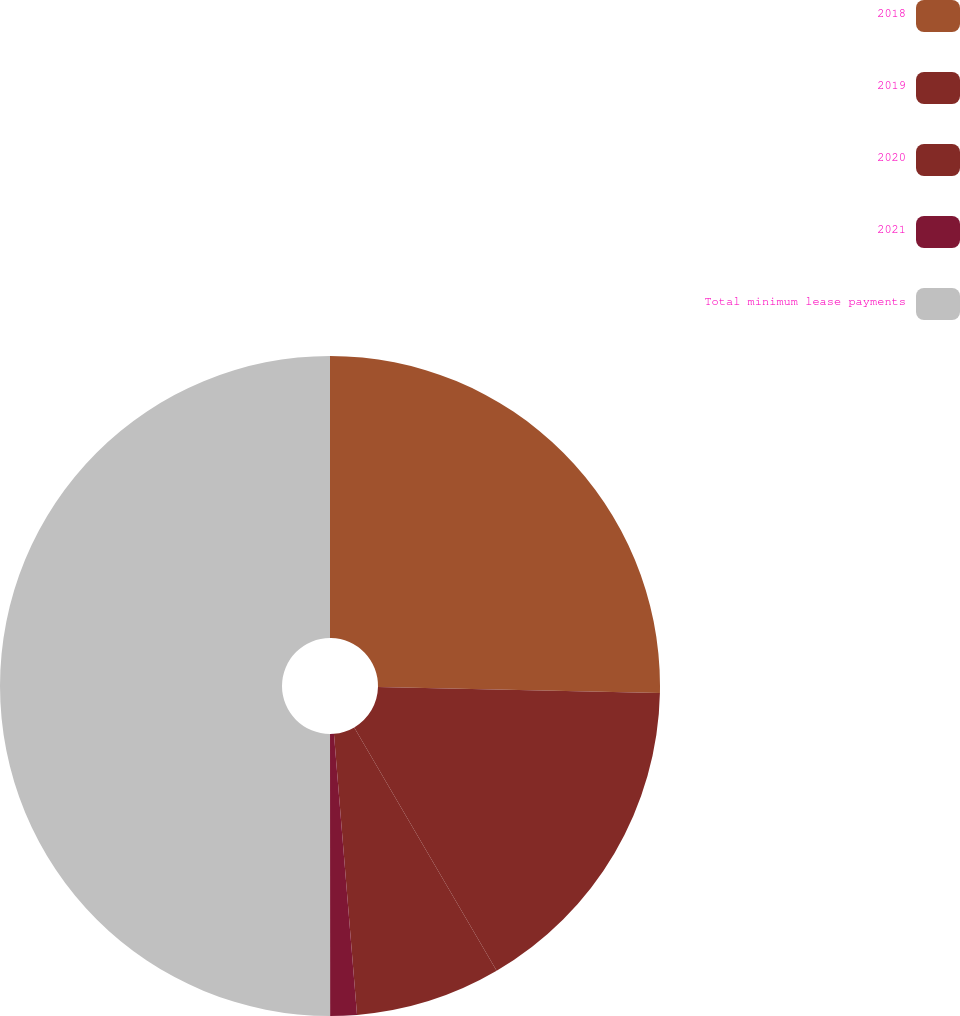Convert chart to OTSL. <chart><loc_0><loc_0><loc_500><loc_500><pie_chart><fcel>2018<fcel>2019<fcel>2020<fcel>2021<fcel>Total minimum lease payments<nl><fcel>25.34%<fcel>16.23%<fcel>7.12%<fcel>1.3%<fcel>50.0%<nl></chart> 